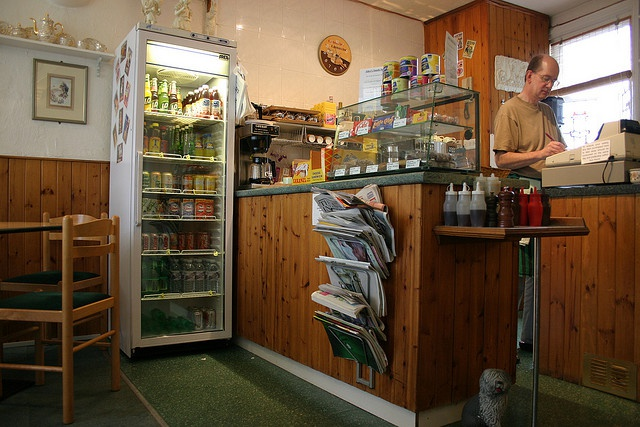Describe the objects in this image and their specific colors. I can see refrigerator in gray, black, darkgray, and darkgreen tones, chair in gray, black, maroon, and brown tones, people in gray, brown, and maroon tones, bottle in gray, olive, black, and maroon tones, and chair in gray, black, maroon, and brown tones in this image. 